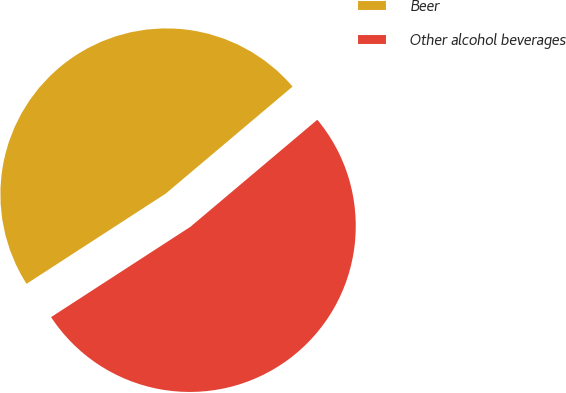<chart> <loc_0><loc_0><loc_500><loc_500><pie_chart><fcel>Beer<fcel>Other alcohol beverages<nl><fcel>48.0%<fcel>52.0%<nl></chart> 